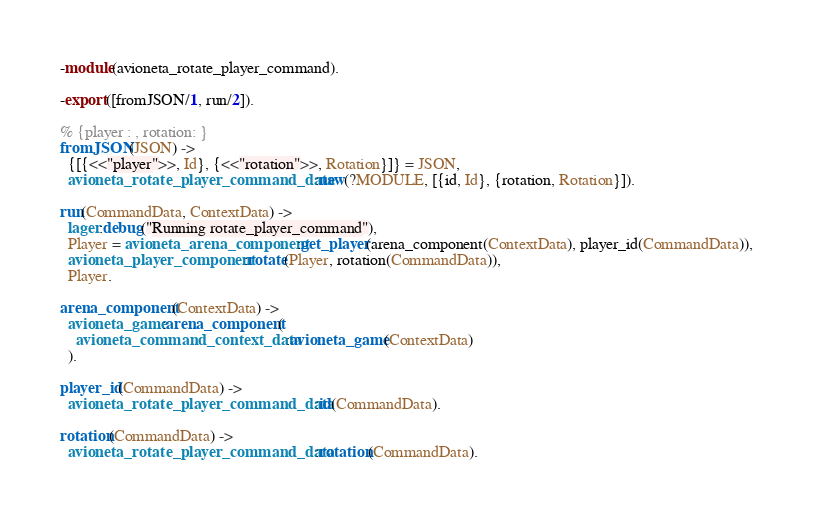Convert code to text. <code><loc_0><loc_0><loc_500><loc_500><_Erlang_>-module(avioneta_rotate_player_command).

-export([fromJSON/1, run/2]).

% {player : , rotation: }
fromJSON(JSON) ->
  {[{<<"player">>, Id}, {<<"rotation">>, Rotation}]} = JSON,
  avioneta_rotate_player_command_data:new(?MODULE, [{id, Id}, {rotation, Rotation}]).

run(CommandData, ContextData) ->
  lager:debug("Running rotate_player_command"),
  Player = avioneta_arena_component:get_player(arena_component(ContextData), player_id(CommandData)),
  avioneta_player_component:rotate(Player, rotation(CommandData)),
  Player.

arena_component(ContextData) ->
  avioneta_game:arena_component(
    avioneta_command_context_data:avioneta_game(ContextData)
  ).

player_id(CommandData) ->
  avioneta_rotate_player_command_data:id(CommandData).

rotation(CommandData) ->
  avioneta_rotate_player_command_data:rotation(CommandData).
</code> 